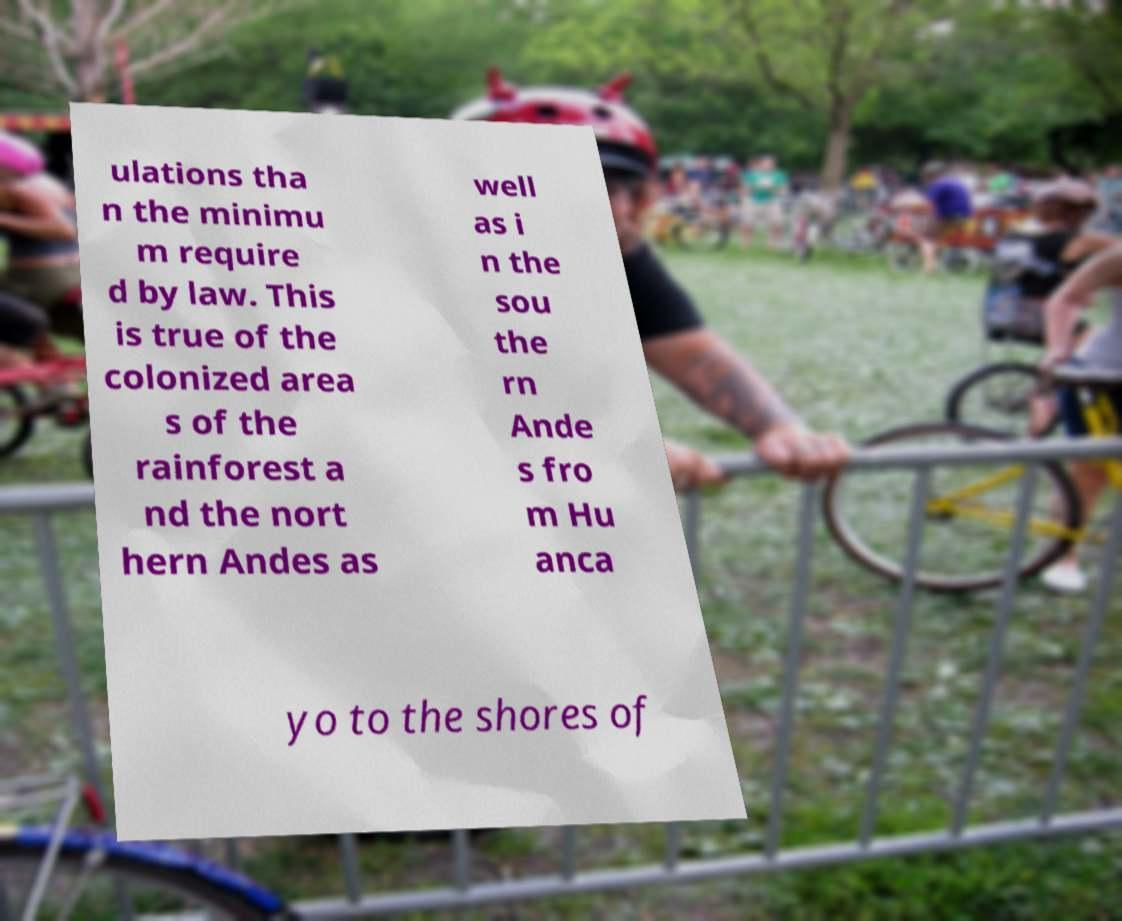For documentation purposes, I need the text within this image transcribed. Could you provide that? ulations tha n the minimu m require d by law. This is true of the colonized area s of the rainforest a nd the nort hern Andes as well as i n the sou the rn Ande s fro m Hu anca yo to the shores of 